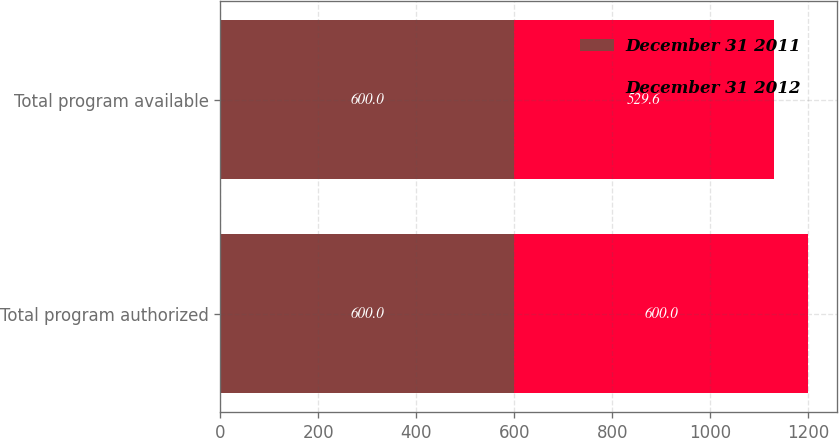Convert chart. <chart><loc_0><loc_0><loc_500><loc_500><stacked_bar_chart><ecel><fcel>Total program authorized<fcel>Total program available<nl><fcel>December 31 2011<fcel>600<fcel>600<nl><fcel>December 31 2012<fcel>600<fcel>529.6<nl></chart> 